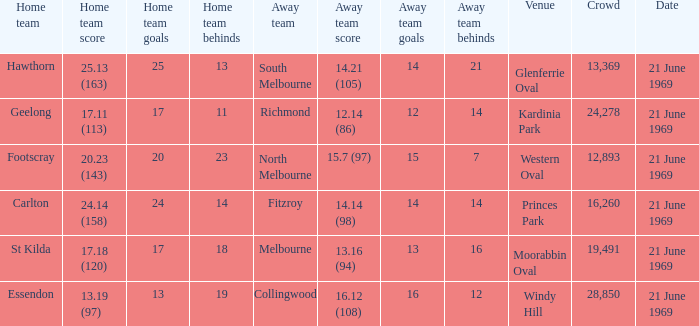When was there a game at Kardinia Park? 21 June 1969. 